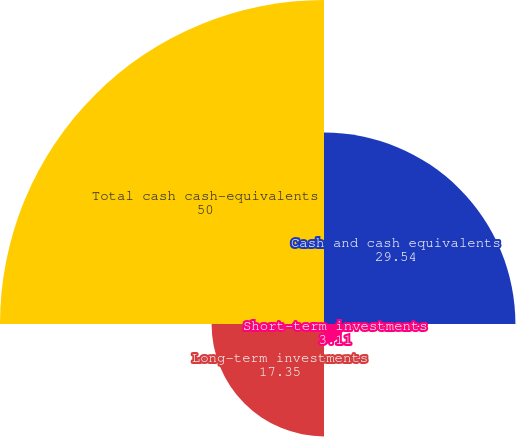Convert chart to OTSL. <chart><loc_0><loc_0><loc_500><loc_500><pie_chart><fcel>Cash and cash equivalents<fcel>Short-term investments<fcel>Long-term investments<fcel>Total cash cash-equivalents<nl><fcel>29.54%<fcel>3.11%<fcel>17.35%<fcel>50.0%<nl></chart> 